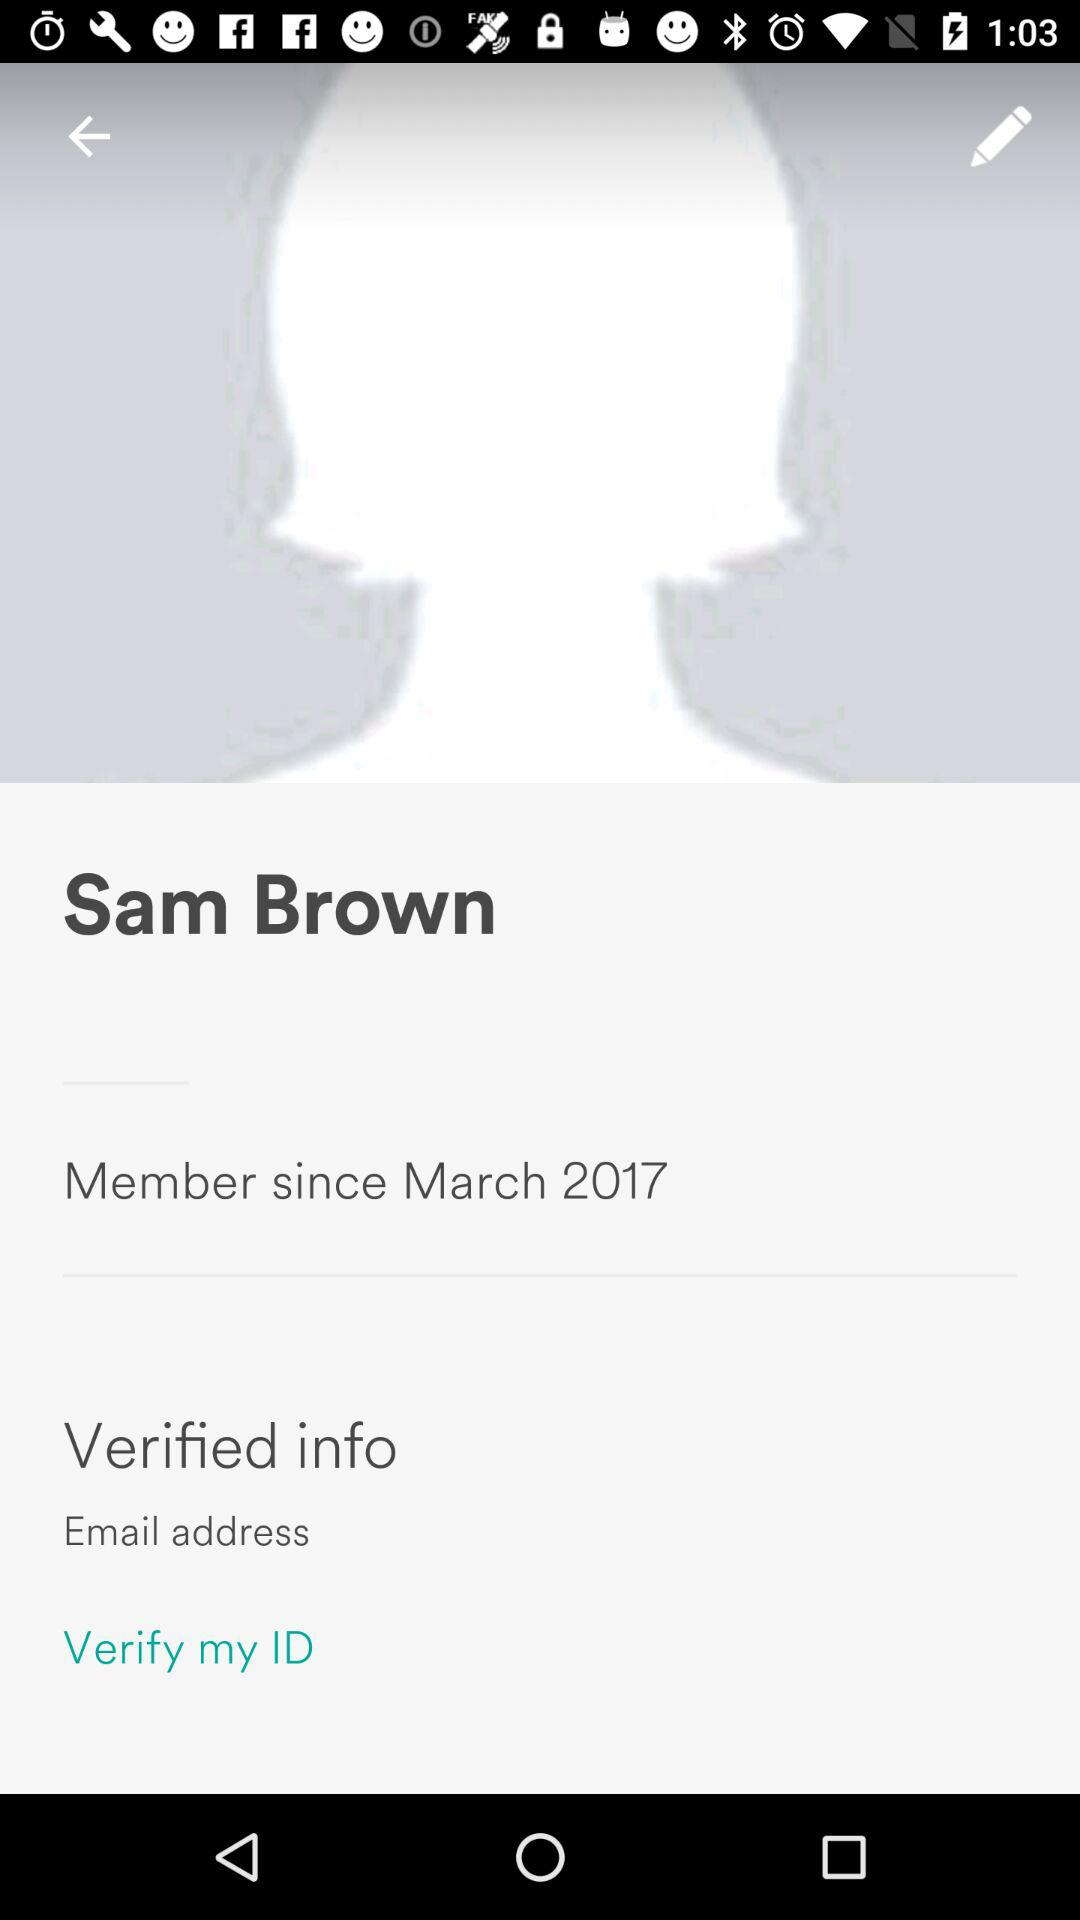What is the given profile name? The given profile name is Sam Brown. 